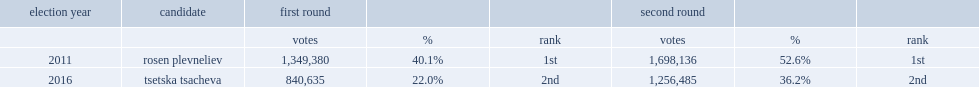In the 2011 election, what the percent of the gerb's candidate rosen plevneliev won the second ballot with of the vote? 52.6. 